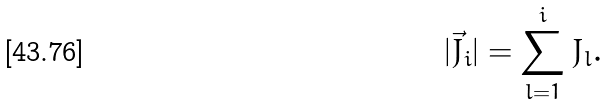<formula> <loc_0><loc_0><loc_500><loc_500>| \vec { J } _ { i } | = \sum _ { l = 1 } ^ { i } J _ { l } .</formula> 